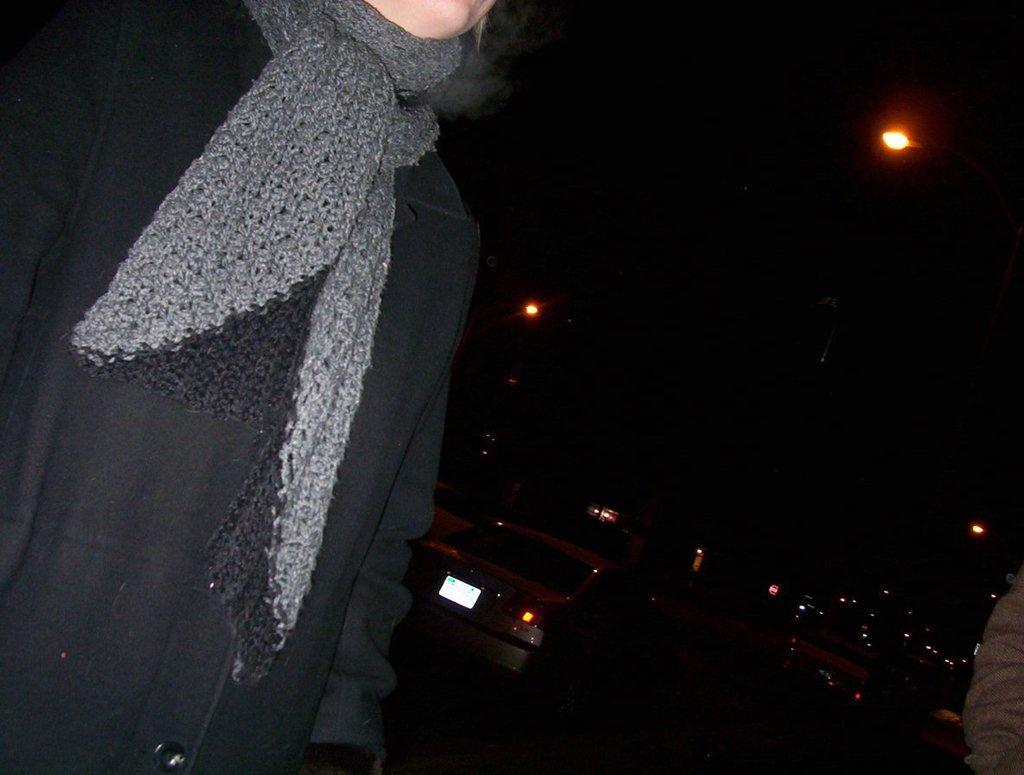How would you summarize this image in a sentence or two? On the left we can see a person. In the background there are vehicles on the road,street lights and on the right at the bottom corner we can see a person hand. 